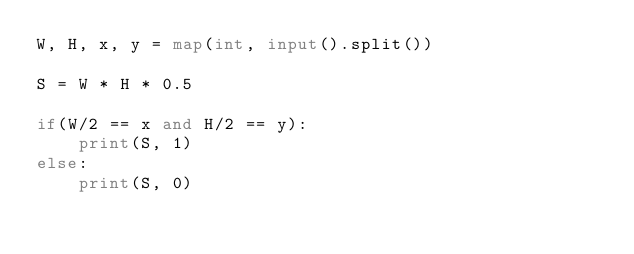<code> <loc_0><loc_0><loc_500><loc_500><_Python_>W, H, x, y = map(int, input().split())

S = W * H * 0.5

if(W/2 == x and H/2 == y):
    print(S, 1)
else:
    print(S, 0)
</code> 